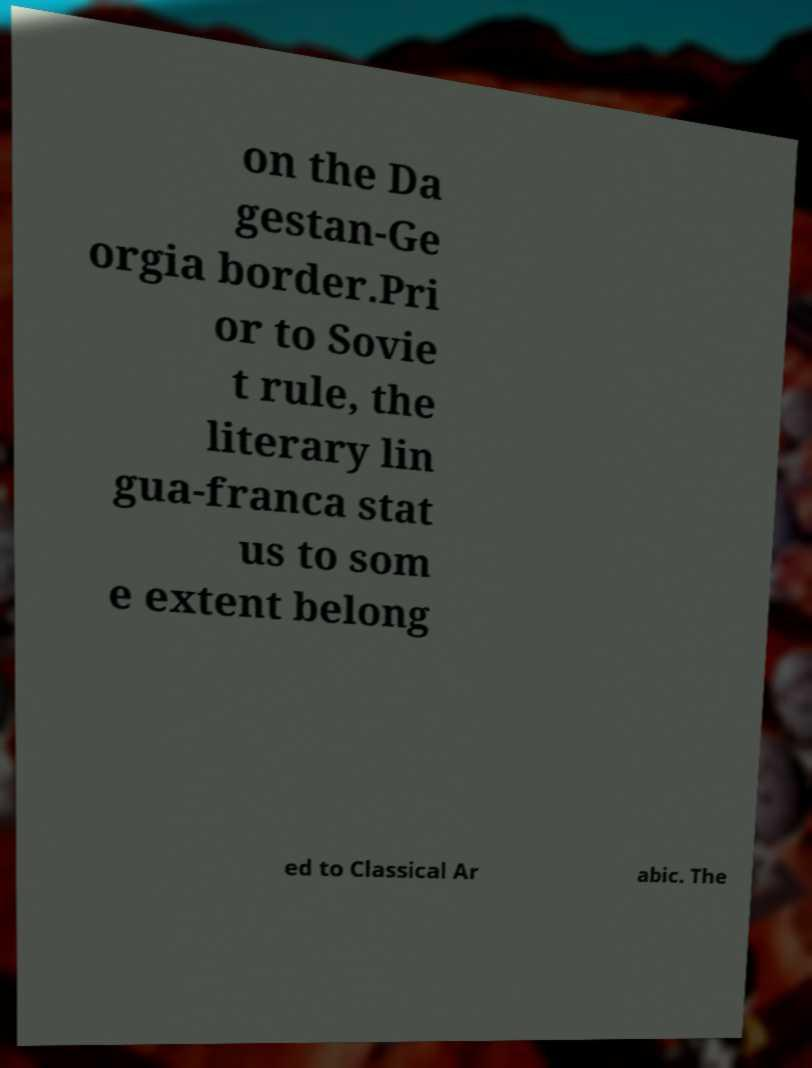Please identify and transcribe the text found in this image. on the Da gestan-Ge orgia border.Pri or to Sovie t rule, the literary lin gua-franca stat us to som e extent belong ed to Classical Ar abic. The 